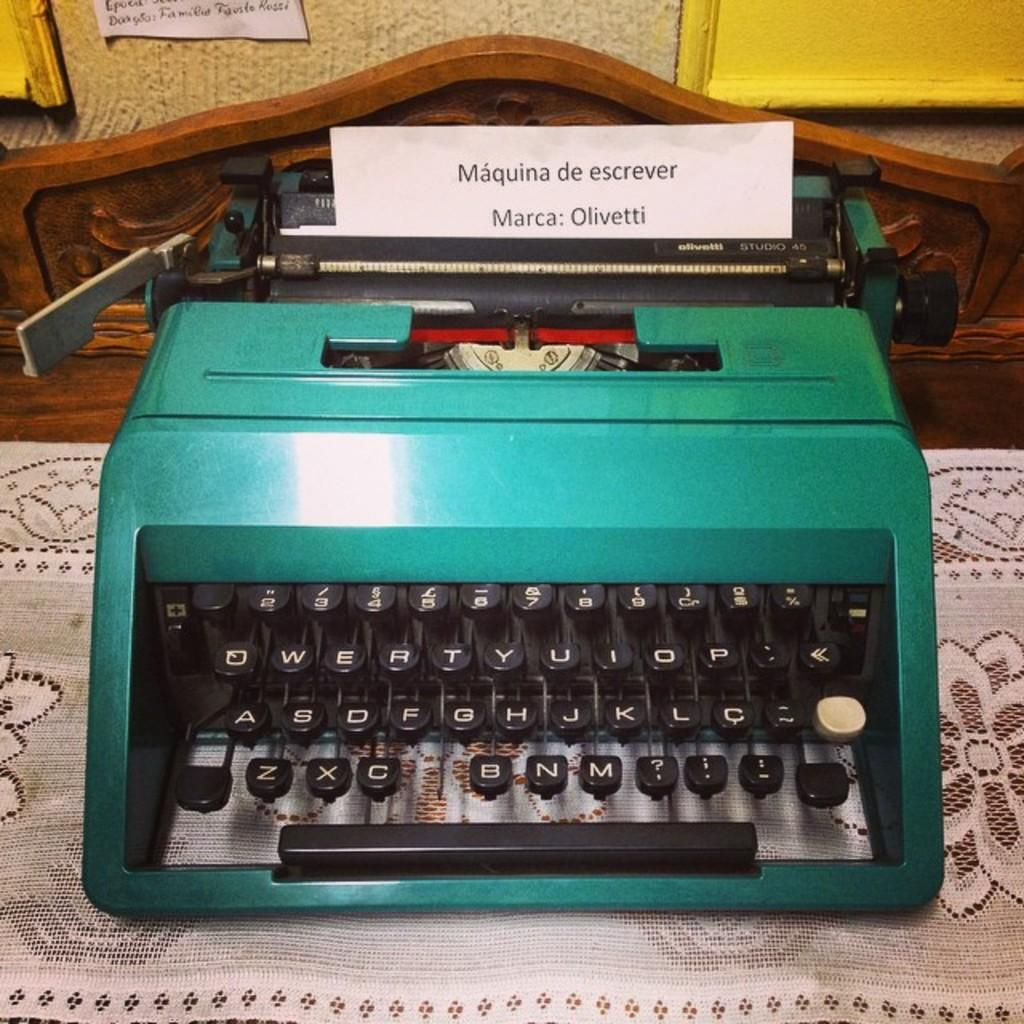<image>
Write a terse but informative summary of the picture. An old teal colored typewriter that has a typed sheet of paper with Maquina de escrever marca: Olivetti typed on it 